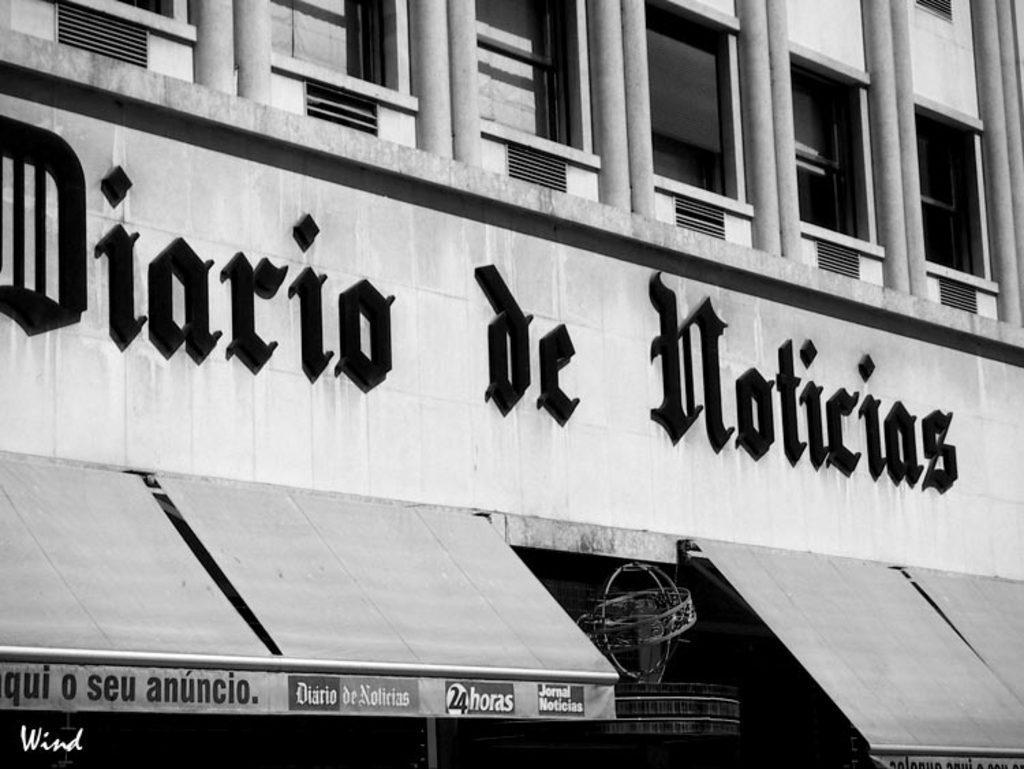In one or two sentences, can you explain what this image depicts? I see this is a black and white image and I see the building on which there are pillars, windows and I see words written over here and I see the sheds and I see few words written over here too and it is dark over here. 